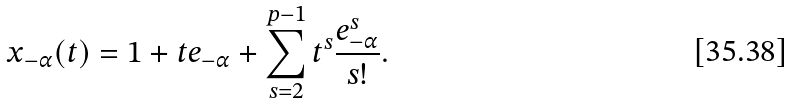<formula> <loc_0><loc_0><loc_500><loc_500>x _ { - \alpha } ( t ) = 1 + t e _ { - \alpha } + \sum _ { s = 2 } ^ { p - 1 } t ^ { s } \frac { e _ { - \alpha } ^ { s } } { s ! } .</formula> 